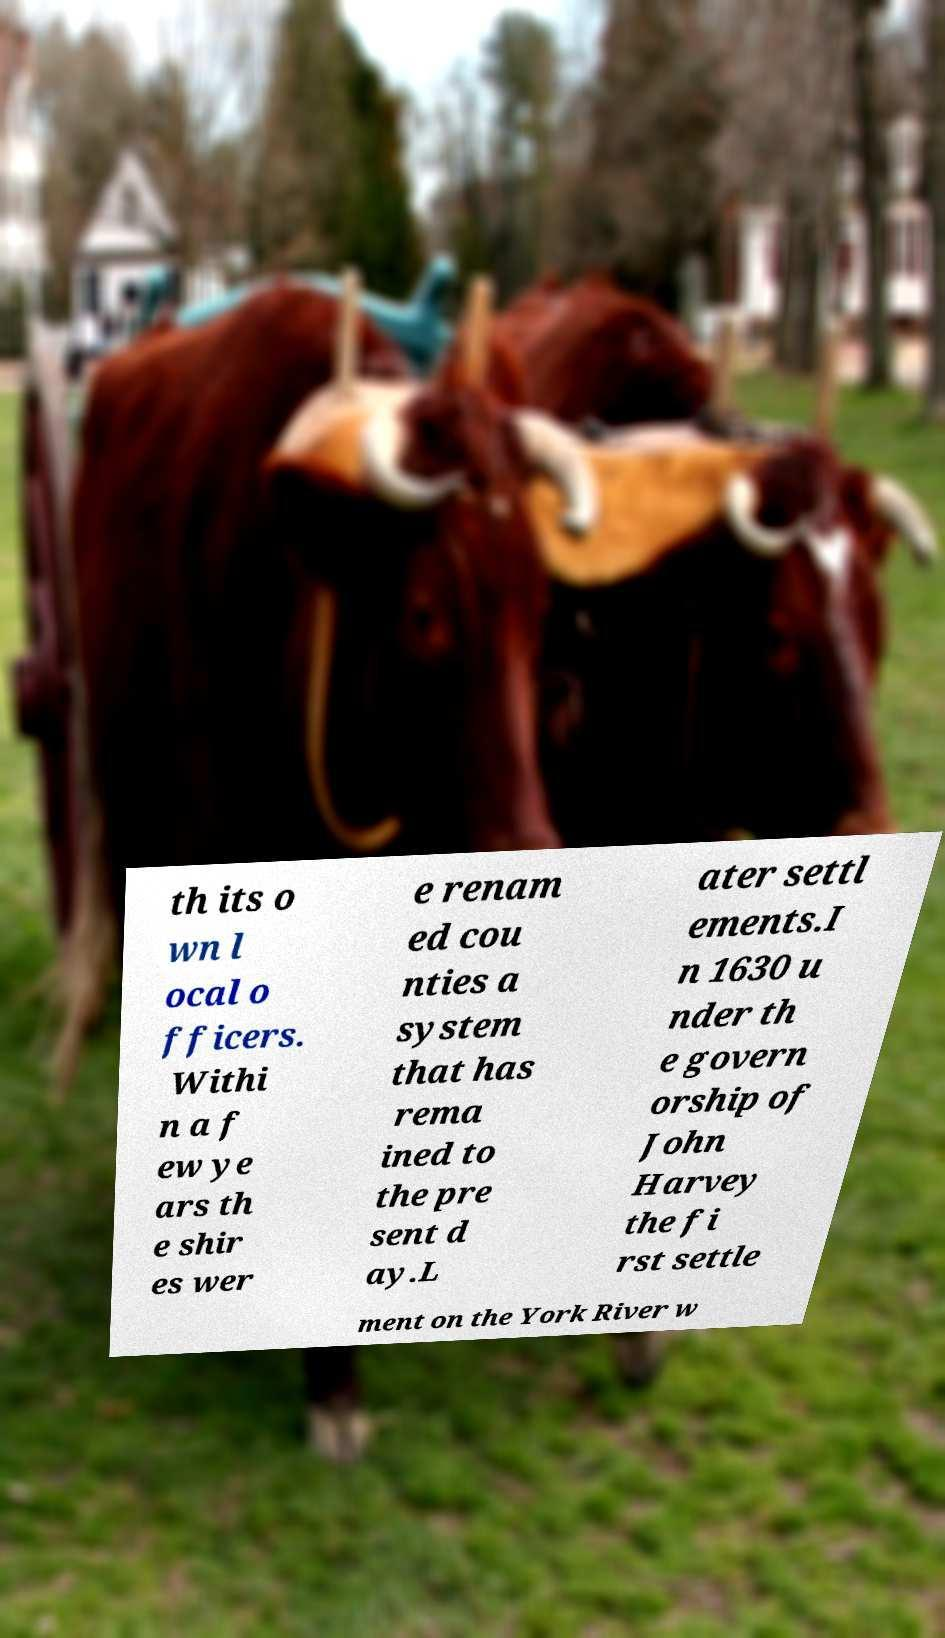For documentation purposes, I need the text within this image transcribed. Could you provide that? th its o wn l ocal o fficers. Withi n a f ew ye ars th e shir es wer e renam ed cou nties a system that has rema ined to the pre sent d ay.L ater settl ements.I n 1630 u nder th e govern orship of John Harvey the fi rst settle ment on the York River w 